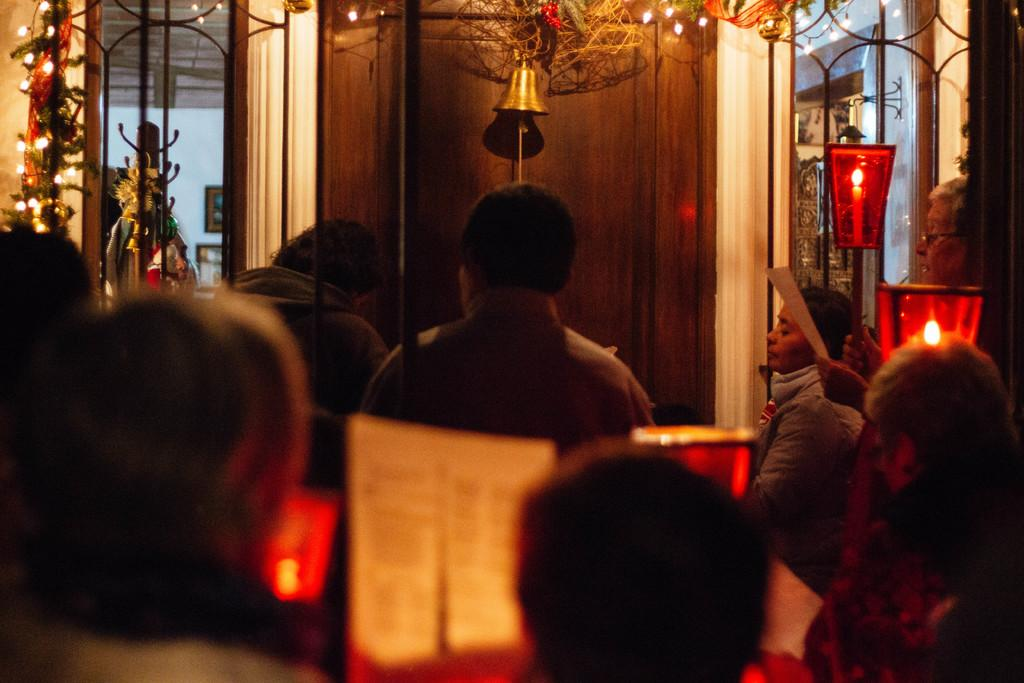What are the people in the image doing? There are people seated in the image. What type of lighting is present in the image? There are candle lights and serial lights in the image. What object can be used to make a sound in the image? There is a bell in the image. What is the man holding in his hand? The man is holding a paper in his hand. How many chickens are present in the image? There are no chickens present in the image. What type of letter is the man reading in the image? The man is holding a paper in his hand, but there is no indication that he is reading a letter. 